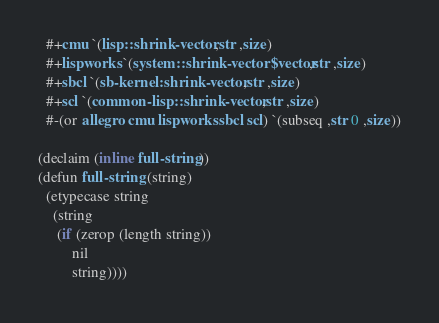Convert code to text. <code><loc_0><loc_0><loc_500><loc_500><_Lisp_>  #+cmu `(lisp::shrink-vector ,str ,size)
  #+lispworks `(system::shrink-vector$vector ,str ,size)
  #+sbcl `(sb-kernel:shrink-vector ,str ,size)
  #+scl `(common-lisp::shrink-vector ,str ,size)
  #-(or allegro cmu lispworks sbcl scl) `(subseq ,str 0 ,size))

(declaim (inline full-string))
(defun full-string (string)
  (etypecase string
    (string
     (if (zerop (length string))
         nil
         string))))
</code> 